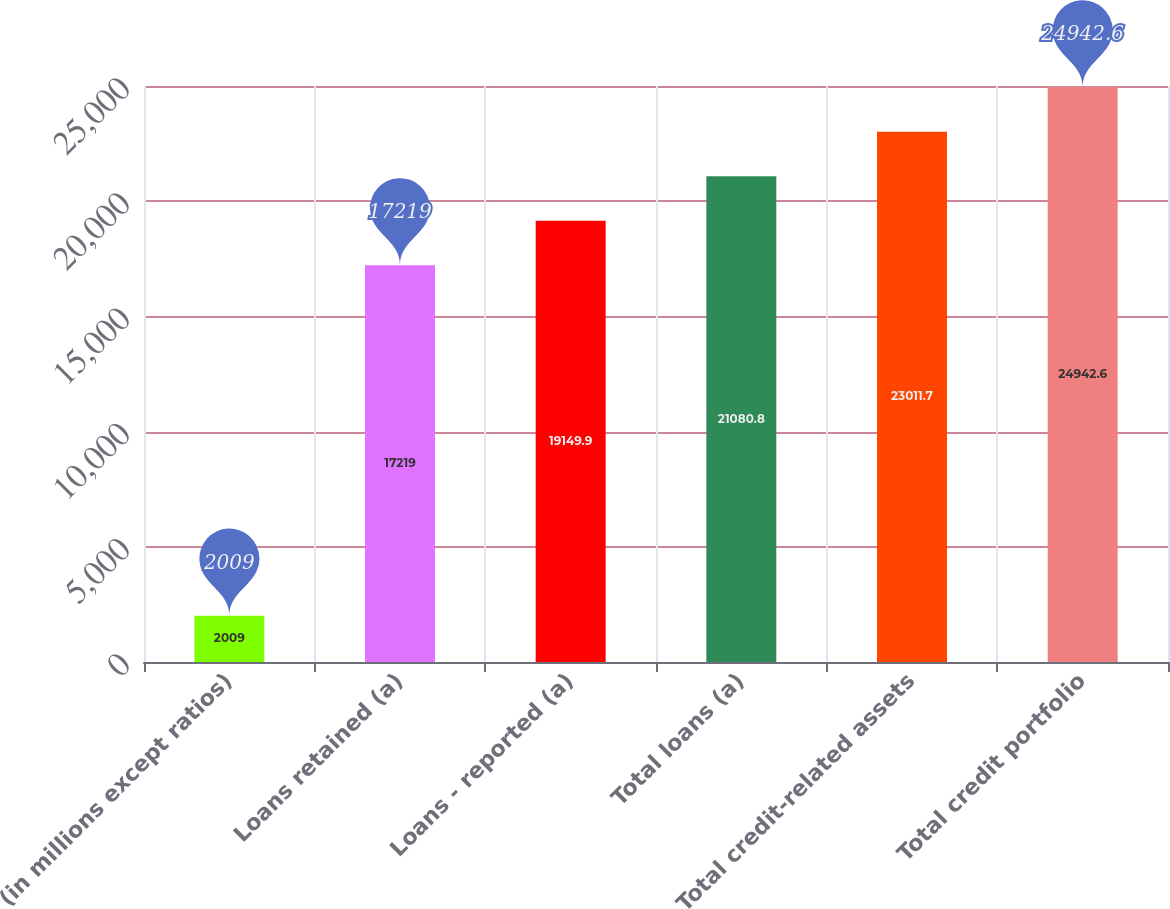<chart> <loc_0><loc_0><loc_500><loc_500><bar_chart><fcel>(in millions except ratios)<fcel>Loans retained (a)<fcel>Loans - reported (a)<fcel>Total loans (a)<fcel>Total credit-related assets<fcel>Total credit portfolio<nl><fcel>2009<fcel>17219<fcel>19149.9<fcel>21080.8<fcel>23011.7<fcel>24942.6<nl></chart> 